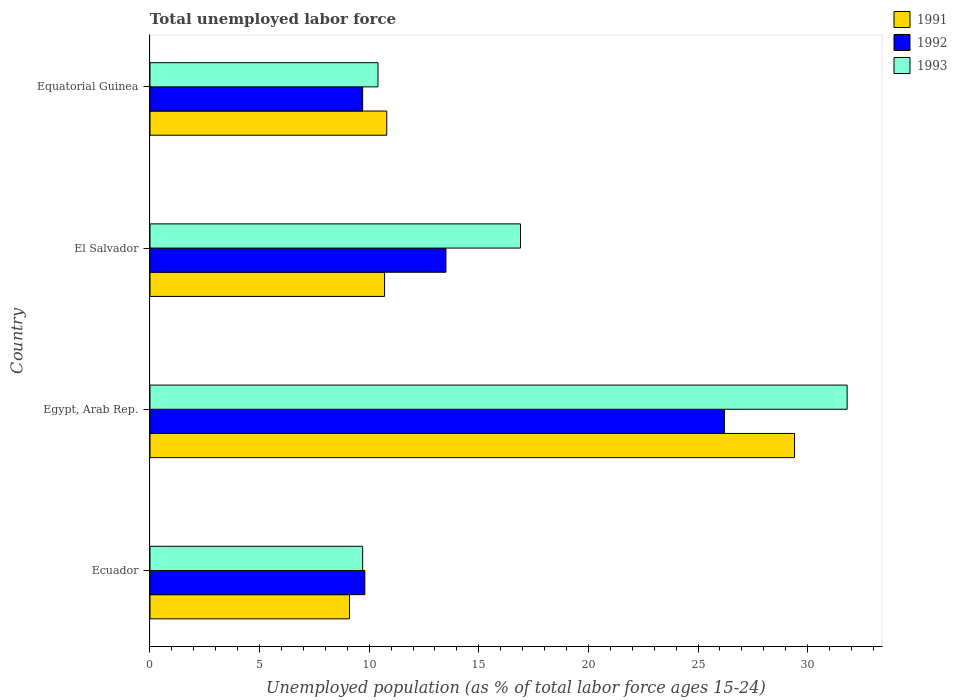How many groups of bars are there?
Offer a very short reply. 4. Are the number of bars per tick equal to the number of legend labels?
Your answer should be compact. Yes. How many bars are there on the 4th tick from the bottom?
Your response must be concise. 3. What is the label of the 2nd group of bars from the top?
Give a very brief answer. El Salvador. What is the percentage of unemployed population in in 1993 in Ecuador?
Ensure brevity in your answer.  9.7. Across all countries, what is the maximum percentage of unemployed population in in 1993?
Make the answer very short. 31.8. Across all countries, what is the minimum percentage of unemployed population in in 1993?
Offer a terse response. 9.7. In which country was the percentage of unemployed population in in 1991 maximum?
Provide a succinct answer. Egypt, Arab Rep. In which country was the percentage of unemployed population in in 1991 minimum?
Provide a succinct answer. Ecuador. What is the total percentage of unemployed population in in 1992 in the graph?
Give a very brief answer. 59.2. What is the difference between the percentage of unemployed population in in 1991 in Ecuador and that in Equatorial Guinea?
Provide a succinct answer. -1.7. What is the difference between the percentage of unemployed population in in 1991 in El Salvador and the percentage of unemployed population in in 1993 in Ecuador?
Provide a succinct answer. 1. What is the average percentage of unemployed population in in 1991 per country?
Your response must be concise. 15. What is the difference between the percentage of unemployed population in in 1992 and percentage of unemployed population in in 1991 in Ecuador?
Offer a very short reply. 0.7. In how many countries, is the percentage of unemployed population in in 1992 greater than 5 %?
Provide a short and direct response. 4. What is the ratio of the percentage of unemployed population in in 1991 in Ecuador to that in El Salvador?
Your answer should be compact. 0.85. Is the percentage of unemployed population in in 1992 in Ecuador less than that in Egypt, Arab Rep.?
Your answer should be very brief. Yes. Is the difference between the percentage of unemployed population in in 1992 in Ecuador and El Salvador greater than the difference between the percentage of unemployed population in in 1991 in Ecuador and El Salvador?
Give a very brief answer. No. What is the difference between the highest and the second highest percentage of unemployed population in in 1991?
Provide a short and direct response. 18.6. What is the difference between the highest and the lowest percentage of unemployed population in in 1991?
Make the answer very short. 20.3. In how many countries, is the percentage of unemployed population in in 1992 greater than the average percentage of unemployed population in in 1992 taken over all countries?
Offer a terse response. 1. What does the 1st bar from the bottom in El Salvador represents?
Offer a very short reply. 1991. How many bars are there?
Your answer should be compact. 12. How many legend labels are there?
Ensure brevity in your answer.  3. How are the legend labels stacked?
Provide a short and direct response. Vertical. What is the title of the graph?
Your answer should be compact. Total unemployed labor force. Does "1978" appear as one of the legend labels in the graph?
Ensure brevity in your answer.  No. What is the label or title of the X-axis?
Provide a short and direct response. Unemployed population (as % of total labor force ages 15-24). What is the Unemployed population (as % of total labor force ages 15-24) of 1991 in Ecuador?
Offer a terse response. 9.1. What is the Unemployed population (as % of total labor force ages 15-24) of 1992 in Ecuador?
Offer a terse response. 9.8. What is the Unemployed population (as % of total labor force ages 15-24) of 1993 in Ecuador?
Provide a succinct answer. 9.7. What is the Unemployed population (as % of total labor force ages 15-24) in 1991 in Egypt, Arab Rep.?
Your answer should be very brief. 29.4. What is the Unemployed population (as % of total labor force ages 15-24) of 1992 in Egypt, Arab Rep.?
Your answer should be compact. 26.2. What is the Unemployed population (as % of total labor force ages 15-24) in 1993 in Egypt, Arab Rep.?
Keep it short and to the point. 31.8. What is the Unemployed population (as % of total labor force ages 15-24) of 1991 in El Salvador?
Give a very brief answer. 10.7. What is the Unemployed population (as % of total labor force ages 15-24) in 1992 in El Salvador?
Keep it short and to the point. 13.5. What is the Unemployed population (as % of total labor force ages 15-24) in 1993 in El Salvador?
Offer a very short reply. 16.9. What is the Unemployed population (as % of total labor force ages 15-24) in 1991 in Equatorial Guinea?
Provide a short and direct response. 10.8. What is the Unemployed population (as % of total labor force ages 15-24) in 1992 in Equatorial Guinea?
Ensure brevity in your answer.  9.7. What is the Unemployed population (as % of total labor force ages 15-24) of 1993 in Equatorial Guinea?
Ensure brevity in your answer.  10.4. Across all countries, what is the maximum Unemployed population (as % of total labor force ages 15-24) in 1991?
Offer a terse response. 29.4. Across all countries, what is the maximum Unemployed population (as % of total labor force ages 15-24) of 1992?
Give a very brief answer. 26.2. Across all countries, what is the maximum Unemployed population (as % of total labor force ages 15-24) of 1993?
Provide a succinct answer. 31.8. Across all countries, what is the minimum Unemployed population (as % of total labor force ages 15-24) of 1991?
Provide a succinct answer. 9.1. Across all countries, what is the minimum Unemployed population (as % of total labor force ages 15-24) of 1992?
Offer a terse response. 9.7. Across all countries, what is the minimum Unemployed population (as % of total labor force ages 15-24) of 1993?
Provide a succinct answer. 9.7. What is the total Unemployed population (as % of total labor force ages 15-24) of 1991 in the graph?
Provide a succinct answer. 60. What is the total Unemployed population (as % of total labor force ages 15-24) in 1992 in the graph?
Provide a succinct answer. 59.2. What is the total Unemployed population (as % of total labor force ages 15-24) in 1993 in the graph?
Provide a short and direct response. 68.8. What is the difference between the Unemployed population (as % of total labor force ages 15-24) of 1991 in Ecuador and that in Egypt, Arab Rep.?
Offer a terse response. -20.3. What is the difference between the Unemployed population (as % of total labor force ages 15-24) in 1992 in Ecuador and that in Egypt, Arab Rep.?
Ensure brevity in your answer.  -16.4. What is the difference between the Unemployed population (as % of total labor force ages 15-24) of 1993 in Ecuador and that in Egypt, Arab Rep.?
Make the answer very short. -22.1. What is the difference between the Unemployed population (as % of total labor force ages 15-24) of 1991 in Ecuador and that in El Salvador?
Provide a short and direct response. -1.6. What is the difference between the Unemployed population (as % of total labor force ages 15-24) in 1991 in Egypt, Arab Rep. and that in El Salvador?
Provide a short and direct response. 18.7. What is the difference between the Unemployed population (as % of total labor force ages 15-24) of 1992 in Egypt, Arab Rep. and that in El Salvador?
Offer a terse response. 12.7. What is the difference between the Unemployed population (as % of total labor force ages 15-24) in 1993 in Egypt, Arab Rep. and that in El Salvador?
Keep it short and to the point. 14.9. What is the difference between the Unemployed population (as % of total labor force ages 15-24) of 1992 in Egypt, Arab Rep. and that in Equatorial Guinea?
Give a very brief answer. 16.5. What is the difference between the Unemployed population (as % of total labor force ages 15-24) of 1993 in Egypt, Arab Rep. and that in Equatorial Guinea?
Offer a terse response. 21.4. What is the difference between the Unemployed population (as % of total labor force ages 15-24) in 1991 in El Salvador and that in Equatorial Guinea?
Your response must be concise. -0.1. What is the difference between the Unemployed population (as % of total labor force ages 15-24) in 1991 in Ecuador and the Unemployed population (as % of total labor force ages 15-24) in 1992 in Egypt, Arab Rep.?
Ensure brevity in your answer.  -17.1. What is the difference between the Unemployed population (as % of total labor force ages 15-24) of 1991 in Ecuador and the Unemployed population (as % of total labor force ages 15-24) of 1993 in Egypt, Arab Rep.?
Provide a succinct answer. -22.7. What is the difference between the Unemployed population (as % of total labor force ages 15-24) in 1992 in Ecuador and the Unemployed population (as % of total labor force ages 15-24) in 1993 in Egypt, Arab Rep.?
Your answer should be very brief. -22. What is the difference between the Unemployed population (as % of total labor force ages 15-24) in 1991 in Ecuador and the Unemployed population (as % of total labor force ages 15-24) in 1992 in El Salvador?
Provide a short and direct response. -4.4. What is the difference between the Unemployed population (as % of total labor force ages 15-24) of 1991 in Ecuador and the Unemployed population (as % of total labor force ages 15-24) of 1992 in Equatorial Guinea?
Keep it short and to the point. -0.6. What is the difference between the Unemployed population (as % of total labor force ages 15-24) in 1991 in Ecuador and the Unemployed population (as % of total labor force ages 15-24) in 1993 in Equatorial Guinea?
Offer a very short reply. -1.3. What is the difference between the Unemployed population (as % of total labor force ages 15-24) of 1991 in Egypt, Arab Rep. and the Unemployed population (as % of total labor force ages 15-24) of 1992 in Equatorial Guinea?
Keep it short and to the point. 19.7. What is the difference between the Unemployed population (as % of total labor force ages 15-24) of 1991 in Egypt, Arab Rep. and the Unemployed population (as % of total labor force ages 15-24) of 1993 in Equatorial Guinea?
Keep it short and to the point. 19. What is the average Unemployed population (as % of total labor force ages 15-24) of 1991 per country?
Your response must be concise. 15. What is the average Unemployed population (as % of total labor force ages 15-24) of 1993 per country?
Keep it short and to the point. 17.2. What is the difference between the Unemployed population (as % of total labor force ages 15-24) of 1991 and Unemployed population (as % of total labor force ages 15-24) of 1992 in Ecuador?
Your answer should be very brief. -0.7. What is the difference between the Unemployed population (as % of total labor force ages 15-24) in 1991 and Unemployed population (as % of total labor force ages 15-24) in 1993 in Ecuador?
Ensure brevity in your answer.  -0.6. What is the difference between the Unemployed population (as % of total labor force ages 15-24) of 1992 and Unemployed population (as % of total labor force ages 15-24) of 1993 in Ecuador?
Your answer should be very brief. 0.1. What is the difference between the Unemployed population (as % of total labor force ages 15-24) in 1991 and Unemployed population (as % of total labor force ages 15-24) in 1992 in Egypt, Arab Rep.?
Your answer should be very brief. 3.2. What is the difference between the Unemployed population (as % of total labor force ages 15-24) in 1991 and Unemployed population (as % of total labor force ages 15-24) in 1993 in Egypt, Arab Rep.?
Your answer should be very brief. -2.4. What is the difference between the Unemployed population (as % of total labor force ages 15-24) in 1991 and Unemployed population (as % of total labor force ages 15-24) in 1992 in El Salvador?
Keep it short and to the point. -2.8. What is the difference between the Unemployed population (as % of total labor force ages 15-24) of 1992 and Unemployed population (as % of total labor force ages 15-24) of 1993 in El Salvador?
Your response must be concise. -3.4. What is the difference between the Unemployed population (as % of total labor force ages 15-24) in 1992 and Unemployed population (as % of total labor force ages 15-24) in 1993 in Equatorial Guinea?
Offer a terse response. -0.7. What is the ratio of the Unemployed population (as % of total labor force ages 15-24) of 1991 in Ecuador to that in Egypt, Arab Rep.?
Your answer should be very brief. 0.31. What is the ratio of the Unemployed population (as % of total labor force ages 15-24) in 1992 in Ecuador to that in Egypt, Arab Rep.?
Give a very brief answer. 0.37. What is the ratio of the Unemployed population (as % of total labor force ages 15-24) of 1993 in Ecuador to that in Egypt, Arab Rep.?
Provide a short and direct response. 0.3. What is the ratio of the Unemployed population (as % of total labor force ages 15-24) of 1991 in Ecuador to that in El Salvador?
Ensure brevity in your answer.  0.85. What is the ratio of the Unemployed population (as % of total labor force ages 15-24) of 1992 in Ecuador to that in El Salvador?
Provide a short and direct response. 0.73. What is the ratio of the Unemployed population (as % of total labor force ages 15-24) of 1993 in Ecuador to that in El Salvador?
Make the answer very short. 0.57. What is the ratio of the Unemployed population (as % of total labor force ages 15-24) in 1991 in Ecuador to that in Equatorial Guinea?
Ensure brevity in your answer.  0.84. What is the ratio of the Unemployed population (as % of total labor force ages 15-24) in 1992 in Ecuador to that in Equatorial Guinea?
Make the answer very short. 1.01. What is the ratio of the Unemployed population (as % of total labor force ages 15-24) in 1993 in Ecuador to that in Equatorial Guinea?
Give a very brief answer. 0.93. What is the ratio of the Unemployed population (as % of total labor force ages 15-24) of 1991 in Egypt, Arab Rep. to that in El Salvador?
Your answer should be very brief. 2.75. What is the ratio of the Unemployed population (as % of total labor force ages 15-24) in 1992 in Egypt, Arab Rep. to that in El Salvador?
Give a very brief answer. 1.94. What is the ratio of the Unemployed population (as % of total labor force ages 15-24) of 1993 in Egypt, Arab Rep. to that in El Salvador?
Your answer should be compact. 1.88. What is the ratio of the Unemployed population (as % of total labor force ages 15-24) of 1991 in Egypt, Arab Rep. to that in Equatorial Guinea?
Keep it short and to the point. 2.72. What is the ratio of the Unemployed population (as % of total labor force ages 15-24) in 1992 in Egypt, Arab Rep. to that in Equatorial Guinea?
Your answer should be compact. 2.7. What is the ratio of the Unemployed population (as % of total labor force ages 15-24) in 1993 in Egypt, Arab Rep. to that in Equatorial Guinea?
Your answer should be very brief. 3.06. What is the ratio of the Unemployed population (as % of total labor force ages 15-24) of 1992 in El Salvador to that in Equatorial Guinea?
Offer a very short reply. 1.39. What is the ratio of the Unemployed population (as % of total labor force ages 15-24) of 1993 in El Salvador to that in Equatorial Guinea?
Your answer should be compact. 1.62. What is the difference between the highest and the second highest Unemployed population (as % of total labor force ages 15-24) of 1991?
Provide a succinct answer. 18.6. What is the difference between the highest and the second highest Unemployed population (as % of total labor force ages 15-24) in 1993?
Offer a terse response. 14.9. What is the difference between the highest and the lowest Unemployed population (as % of total labor force ages 15-24) in 1991?
Your answer should be compact. 20.3. What is the difference between the highest and the lowest Unemployed population (as % of total labor force ages 15-24) of 1992?
Offer a very short reply. 16.5. What is the difference between the highest and the lowest Unemployed population (as % of total labor force ages 15-24) of 1993?
Your response must be concise. 22.1. 